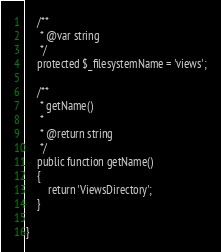Convert code to text. <code><loc_0><loc_0><loc_500><loc_500><_PHP_>
    /**
     * @var string
     */
    protected $_filesystemName = 'views';

    /**
     * getName()
     *
     * @return string
     */
    public function getName()
    {
        return 'ViewsDirectory';
    }

}
</code> 